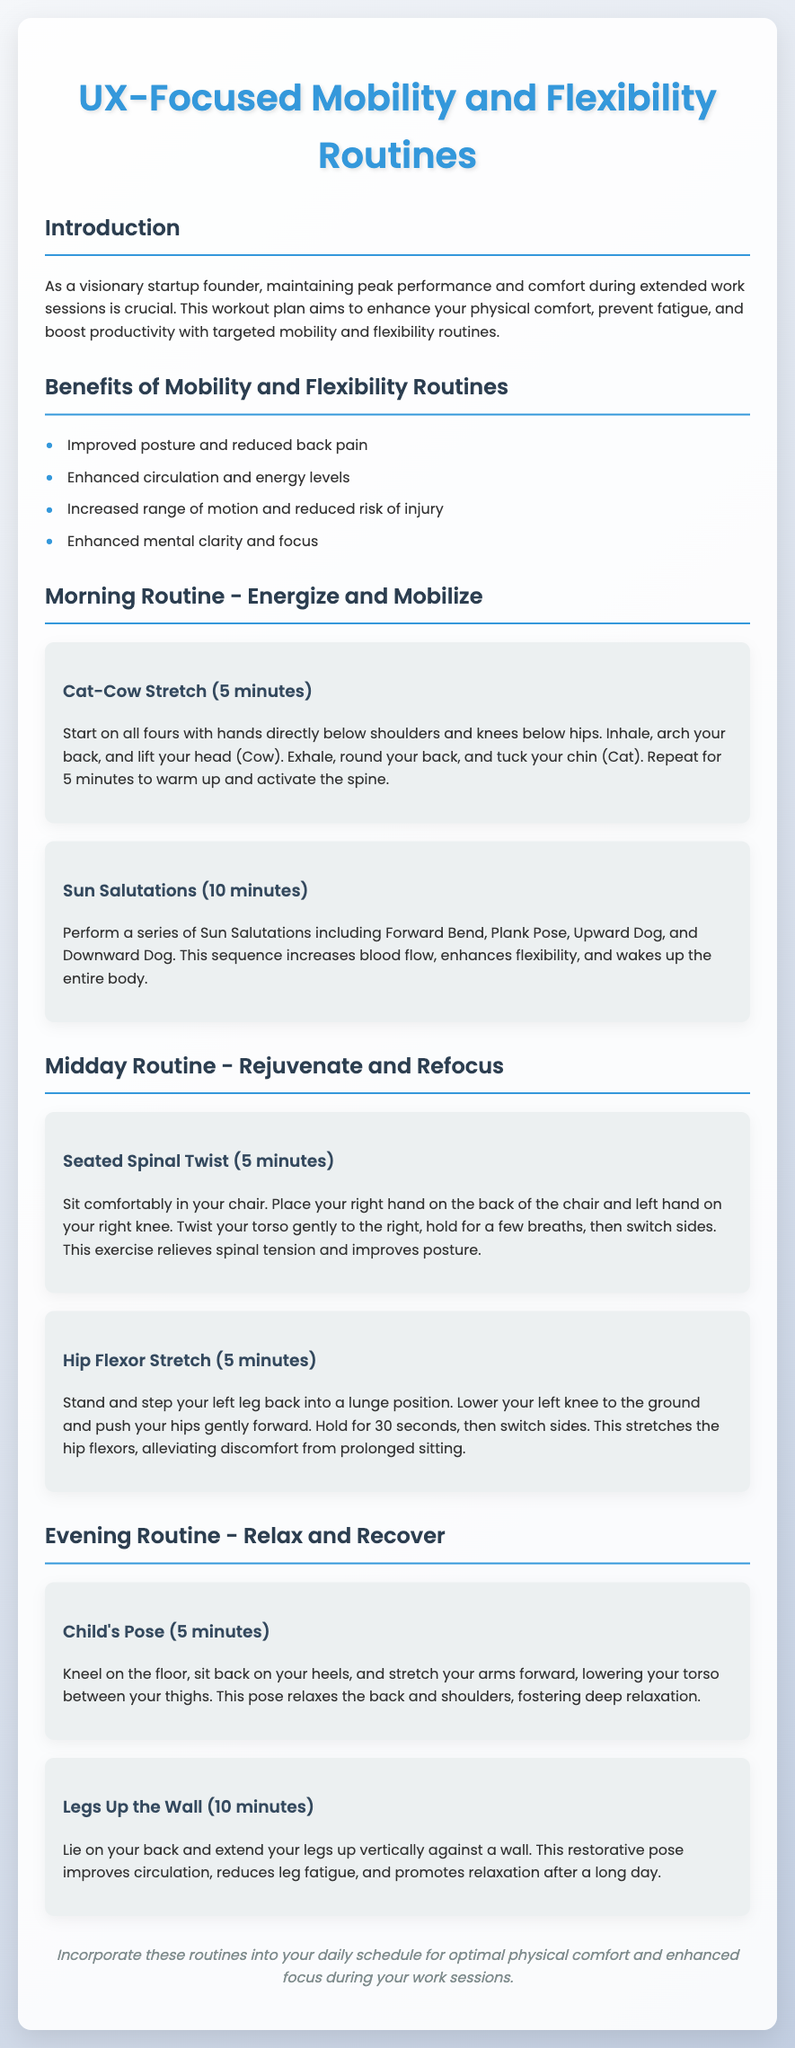what are the benefits of mobility and flexibility routines? The benefits listed in the document include improved posture and reduced back pain, enhanced circulation and energy levels, increased range of motion and reduced risk of injury, and enhanced mental clarity and focus.
Answer: improved posture and reduced back pain, enhanced circulation and energy levels, increased range of motion and reduced risk of injury, enhanced mental clarity and focus how long should you perform the Cat-Cow Stretch? The duration specified for the Cat-Cow Stretch in the document is 5 minutes.
Answer: 5 minutes what is the first exercise in the morning routine? The first exercise mentioned in the morning routine is the Cat-Cow Stretch.
Answer: Cat-Cow Stretch which position is used in the Child's Pose? The position described in the Child's Pose is kneeling on the floor.
Answer: kneeling on the floor how many minutes is the Legs Up the Wall exercise suggested for? The document suggests performing the Legs Up the Wall exercise for 10 minutes.
Answer: 10 minutes what does the Seated Spinal Twist target? The Seated Spinal Twist targets alleviating spinal tension and improving posture.
Answer: alleviating spinal tension and improving posture what is the purpose of Sun Salutations? The purpose of Sun Salutations is to increase blood flow, enhance flexibility, and wake up the entire body.
Answer: increase blood flow, enhance flexibility, and wake up the entire body what is the name of the evening routine? The name of the evening routine mentioned in the document is Relax and Recover.
Answer: Relax and Recover 